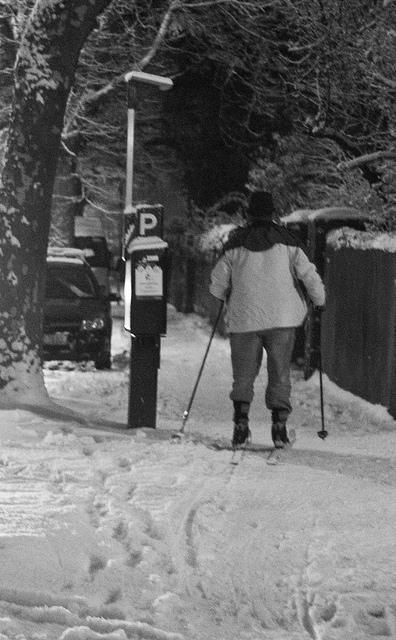How many yellow boats are there?
Give a very brief answer. 0. 